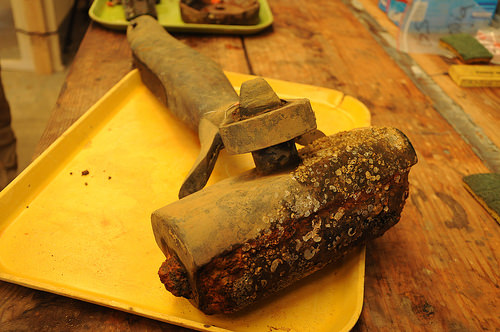<image>
Is there a tool on the table? Yes. Looking at the image, I can see the tool is positioned on top of the table, with the table providing support. 